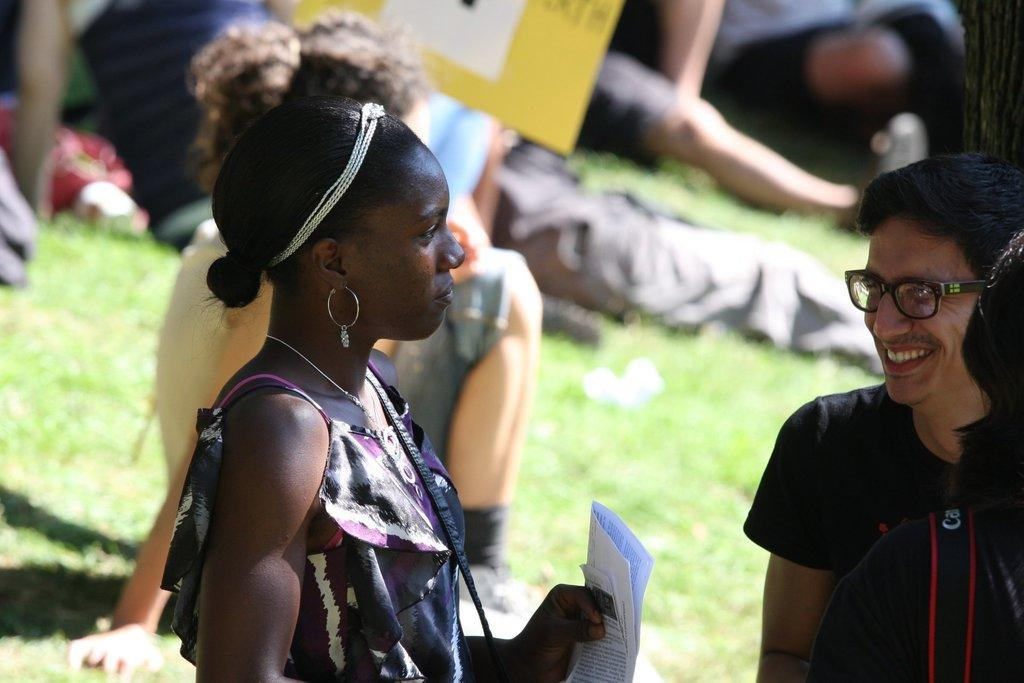What is the woman holding in the image? The woman is holding papers in the image. What is the setting of the image? There are people on the grassland in the image. Can you describe the person on the right side of the image? There is a person wearing spectacles on the right side of the image. What is visible at the top of the image? There is a board visible at the top of the image. What type of cheese is being offered by the woman in the image? There is no cheese present in the image; the woman is holding papers. What hope does the person wearing spectacles have for the future? The image does not provide any information about the person's hopes or future plans. 